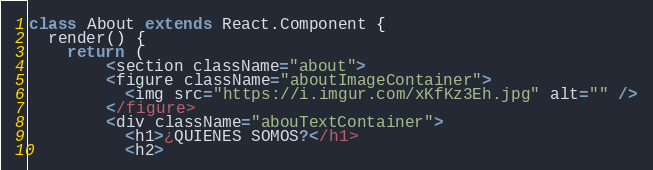<code> <loc_0><loc_0><loc_500><loc_500><_JavaScript_>
class About extends React.Component {
  render() {
    return (
        <section className="about">
        <figure className="aboutImageContainer">
          <img src="https://i.imgur.com/xKfKz3Eh.jpg" alt="" />
        </figure>
        <div className="abouTextContainer">
          <h1>¿QUIENES SOMOS?</h1>
          <h2></code> 